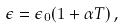<formula> <loc_0><loc_0><loc_500><loc_500>\epsilon = \epsilon _ { 0 } ( 1 + \alpha T ) \, ,</formula> 